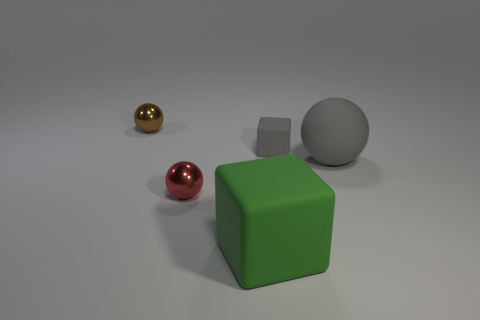There is a matte thing that is the same color as the tiny block; what is its size?
Offer a very short reply. Large. How many cylinders are either gray matte things or small red things?
Give a very brief answer. 0. What shape is the small gray matte thing to the right of the big green thing?
Offer a terse response. Cube. What color is the block on the right side of the matte thing in front of the red metallic sphere that is in front of the small rubber block?
Keep it short and to the point. Gray. Is the material of the tiny brown ball the same as the green block?
Your answer should be compact. No. How many brown objects are either shiny spheres or large blocks?
Your answer should be compact. 1. There is a big cube; what number of things are on the right side of it?
Make the answer very short. 2. Are there more gray blocks than gray matte things?
Your answer should be very brief. No. The small metallic object that is right of the tiny metallic sphere on the left side of the red ball is what shape?
Your answer should be very brief. Sphere. Do the small rubber cube and the big cube have the same color?
Offer a very short reply. No. 